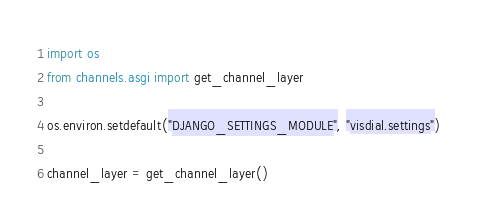Convert code to text. <code><loc_0><loc_0><loc_500><loc_500><_Python_>import os
from channels.asgi import get_channel_layer

os.environ.setdefault("DJANGO_SETTINGS_MODULE", "visdial.settings")

channel_layer = get_channel_layer()
</code> 